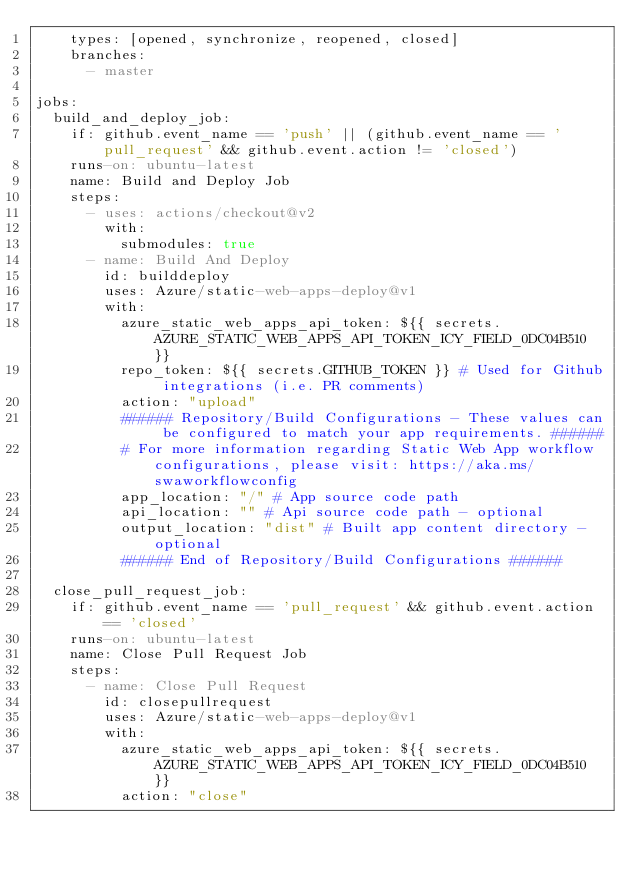Convert code to text. <code><loc_0><loc_0><loc_500><loc_500><_YAML_>    types: [opened, synchronize, reopened, closed]
    branches:
      - master

jobs:
  build_and_deploy_job:
    if: github.event_name == 'push' || (github.event_name == 'pull_request' && github.event.action != 'closed')
    runs-on: ubuntu-latest
    name: Build and Deploy Job
    steps:
      - uses: actions/checkout@v2
        with:
          submodules: true
      - name: Build And Deploy
        id: builddeploy
        uses: Azure/static-web-apps-deploy@v1
        with:
          azure_static_web_apps_api_token: ${{ secrets.AZURE_STATIC_WEB_APPS_API_TOKEN_ICY_FIELD_0DC04B510 }}
          repo_token: ${{ secrets.GITHUB_TOKEN }} # Used for Github integrations (i.e. PR comments)
          action: "upload"
          ###### Repository/Build Configurations - These values can be configured to match your app requirements. ######
          # For more information regarding Static Web App workflow configurations, please visit: https://aka.ms/swaworkflowconfig
          app_location: "/" # App source code path
          api_location: "" # Api source code path - optional
          output_location: "dist" # Built app content directory - optional
          ###### End of Repository/Build Configurations ######

  close_pull_request_job:
    if: github.event_name == 'pull_request' && github.event.action == 'closed'
    runs-on: ubuntu-latest
    name: Close Pull Request Job
    steps:
      - name: Close Pull Request
        id: closepullrequest
        uses: Azure/static-web-apps-deploy@v1
        with:
          azure_static_web_apps_api_token: ${{ secrets.AZURE_STATIC_WEB_APPS_API_TOKEN_ICY_FIELD_0DC04B510 }}
          action: "close"
</code> 